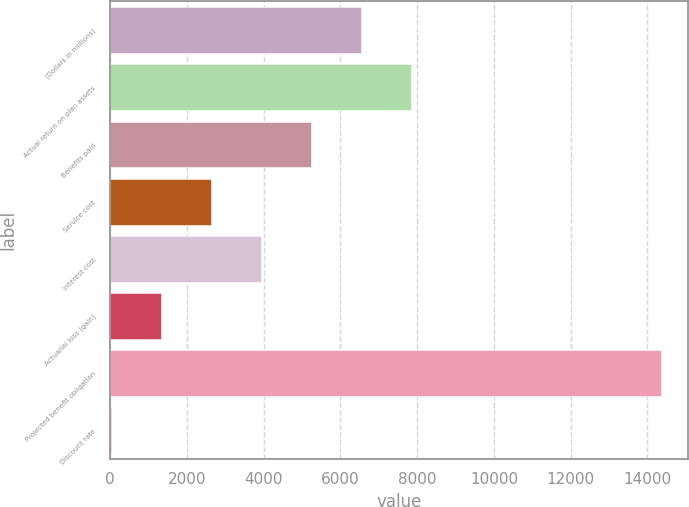<chart> <loc_0><loc_0><loc_500><loc_500><bar_chart><fcel>(Dollars in millions)<fcel>Actual return on plan assets<fcel>Benefits paid<fcel>Service cost<fcel>Interest cost<fcel>Actuarial loss (gain)<fcel>Projected benefit obligation<fcel>Discount rate<nl><fcel>6526.88<fcel>7831.11<fcel>5222.65<fcel>2614.2<fcel>3918.43<fcel>1309.98<fcel>14352.2<fcel>5.75<nl></chart> 